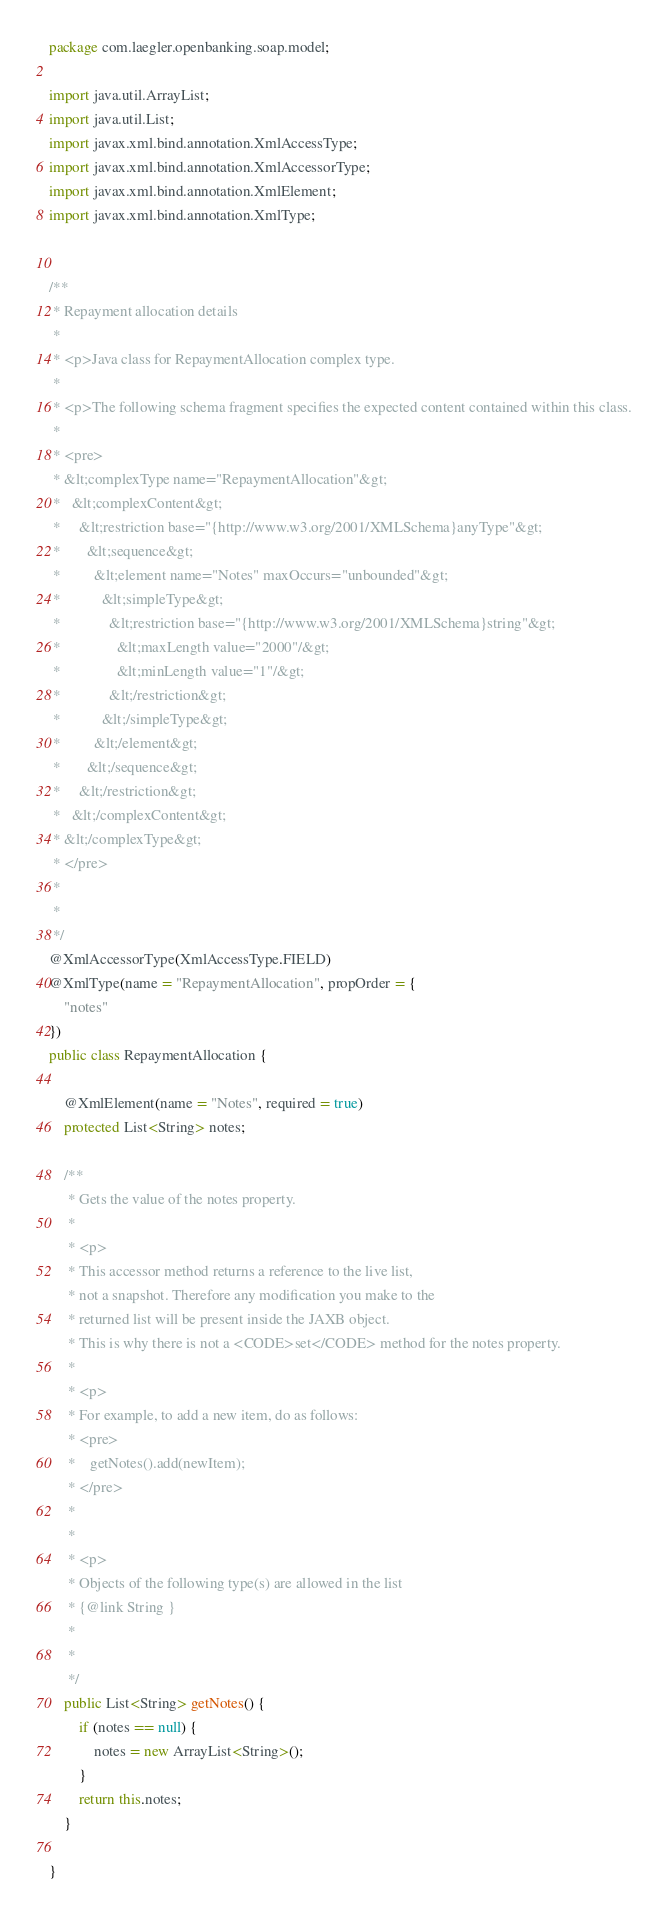Convert code to text. <code><loc_0><loc_0><loc_500><loc_500><_Java_>
package com.laegler.openbanking.soap.model;

import java.util.ArrayList;
import java.util.List;
import javax.xml.bind.annotation.XmlAccessType;
import javax.xml.bind.annotation.XmlAccessorType;
import javax.xml.bind.annotation.XmlElement;
import javax.xml.bind.annotation.XmlType;


/**
 * Repayment allocation details
 * 
 * <p>Java class for RepaymentAllocation complex type.
 * 
 * <p>The following schema fragment specifies the expected content contained within this class.
 * 
 * <pre>
 * &lt;complexType name="RepaymentAllocation"&gt;
 *   &lt;complexContent&gt;
 *     &lt;restriction base="{http://www.w3.org/2001/XMLSchema}anyType"&gt;
 *       &lt;sequence&gt;
 *         &lt;element name="Notes" maxOccurs="unbounded"&gt;
 *           &lt;simpleType&gt;
 *             &lt;restriction base="{http://www.w3.org/2001/XMLSchema}string"&gt;
 *               &lt;maxLength value="2000"/&gt;
 *               &lt;minLength value="1"/&gt;
 *             &lt;/restriction&gt;
 *           &lt;/simpleType&gt;
 *         &lt;/element&gt;
 *       &lt;/sequence&gt;
 *     &lt;/restriction&gt;
 *   &lt;/complexContent&gt;
 * &lt;/complexType&gt;
 * </pre>
 * 
 * 
 */
@XmlAccessorType(XmlAccessType.FIELD)
@XmlType(name = "RepaymentAllocation", propOrder = {
    "notes"
})
public class RepaymentAllocation {

    @XmlElement(name = "Notes", required = true)
    protected List<String> notes;

    /**
     * Gets the value of the notes property.
     * 
     * <p>
     * This accessor method returns a reference to the live list,
     * not a snapshot. Therefore any modification you make to the
     * returned list will be present inside the JAXB object.
     * This is why there is not a <CODE>set</CODE> method for the notes property.
     * 
     * <p>
     * For example, to add a new item, do as follows:
     * <pre>
     *    getNotes().add(newItem);
     * </pre>
     * 
     * 
     * <p>
     * Objects of the following type(s) are allowed in the list
     * {@link String }
     * 
     * 
     */
    public List<String> getNotes() {
        if (notes == null) {
            notes = new ArrayList<String>();
        }
        return this.notes;
    }

}
</code> 